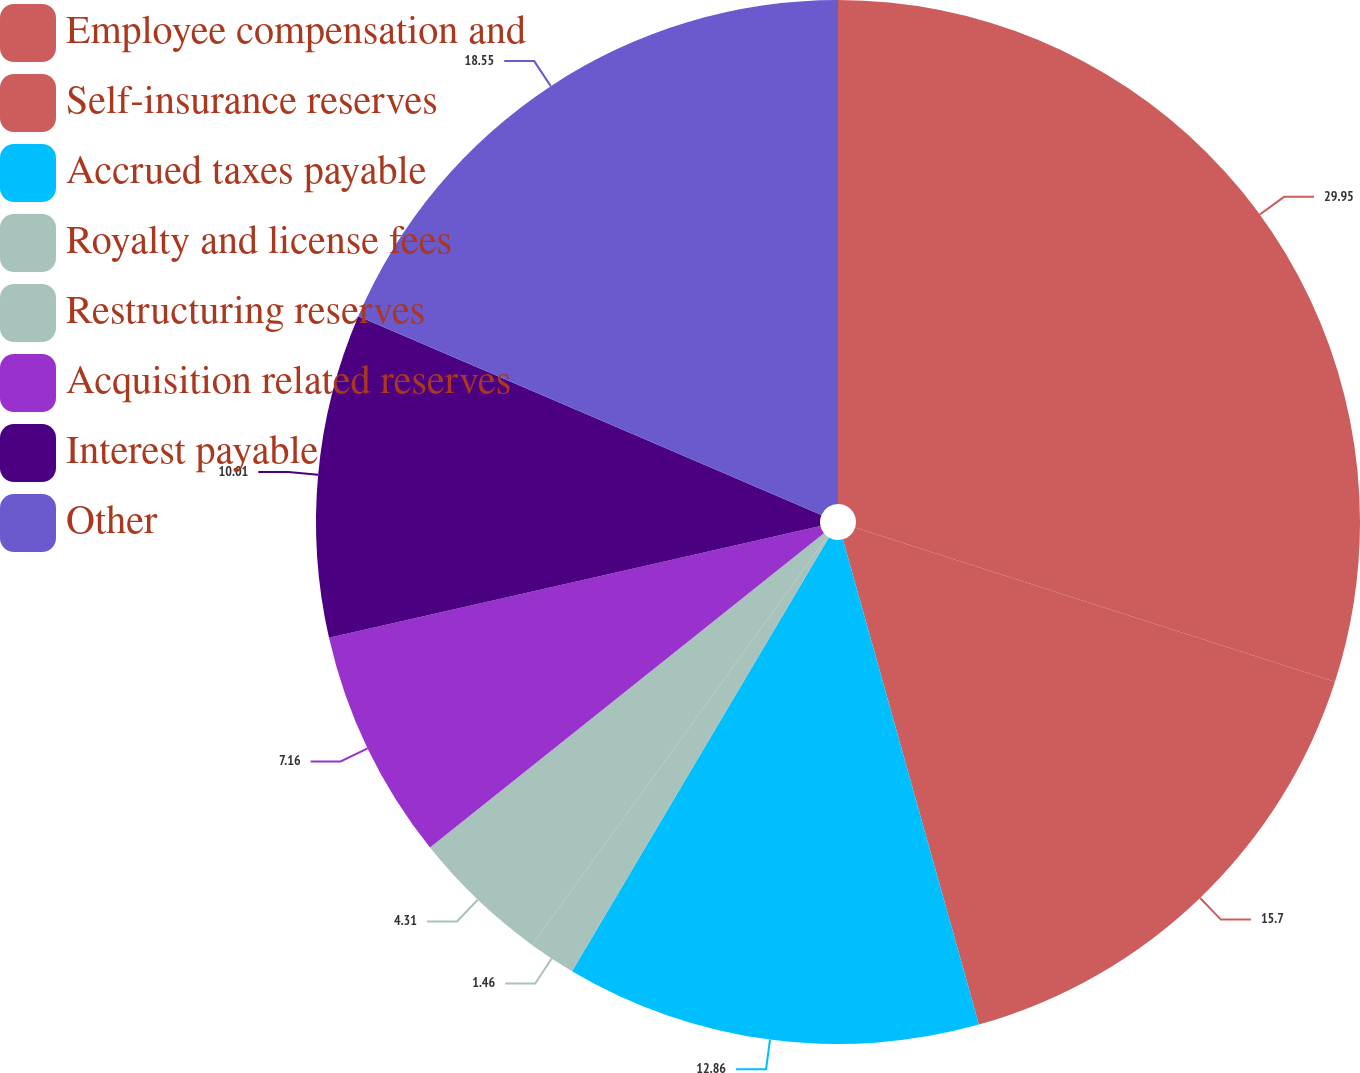Convert chart. <chart><loc_0><loc_0><loc_500><loc_500><pie_chart><fcel>Employee compensation and<fcel>Self-insurance reserves<fcel>Accrued taxes payable<fcel>Royalty and license fees<fcel>Restructuring reserves<fcel>Acquisition related reserves<fcel>Interest payable<fcel>Other<nl><fcel>29.95%<fcel>15.7%<fcel>12.86%<fcel>1.46%<fcel>4.31%<fcel>7.16%<fcel>10.01%<fcel>18.55%<nl></chart> 